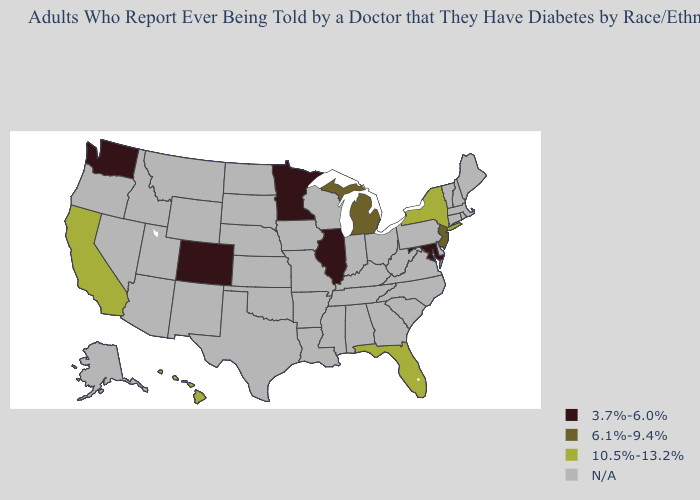Name the states that have a value in the range 10.5%-13.2%?
Keep it brief. California, Florida, Hawaii, New York. What is the value of Louisiana?
Short answer required. N/A. What is the value of Louisiana?
Answer briefly. N/A. Which states hav the highest value in the MidWest?
Answer briefly. Michigan. Which states hav the highest value in the West?
Answer briefly. California, Hawaii. Does the first symbol in the legend represent the smallest category?
Be succinct. Yes. What is the highest value in the USA?
Answer briefly. 10.5%-13.2%. Name the states that have a value in the range 3.7%-6.0%?
Quick response, please. Colorado, Illinois, Maryland, Minnesota, Washington. What is the value of Illinois?
Be succinct. 3.7%-6.0%. Which states have the lowest value in the MidWest?
Give a very brief answer. Illinois, Minnesota. What is the value of California?
Answer briefly. 10.5%-13.2%. What is the value of Colorado?
Answer briefly. 3.7%-6.0%. Is the legend a continuous bar?
Write a very short answer. No. What is the value of Nevada?
Concise answer only. N/A. 